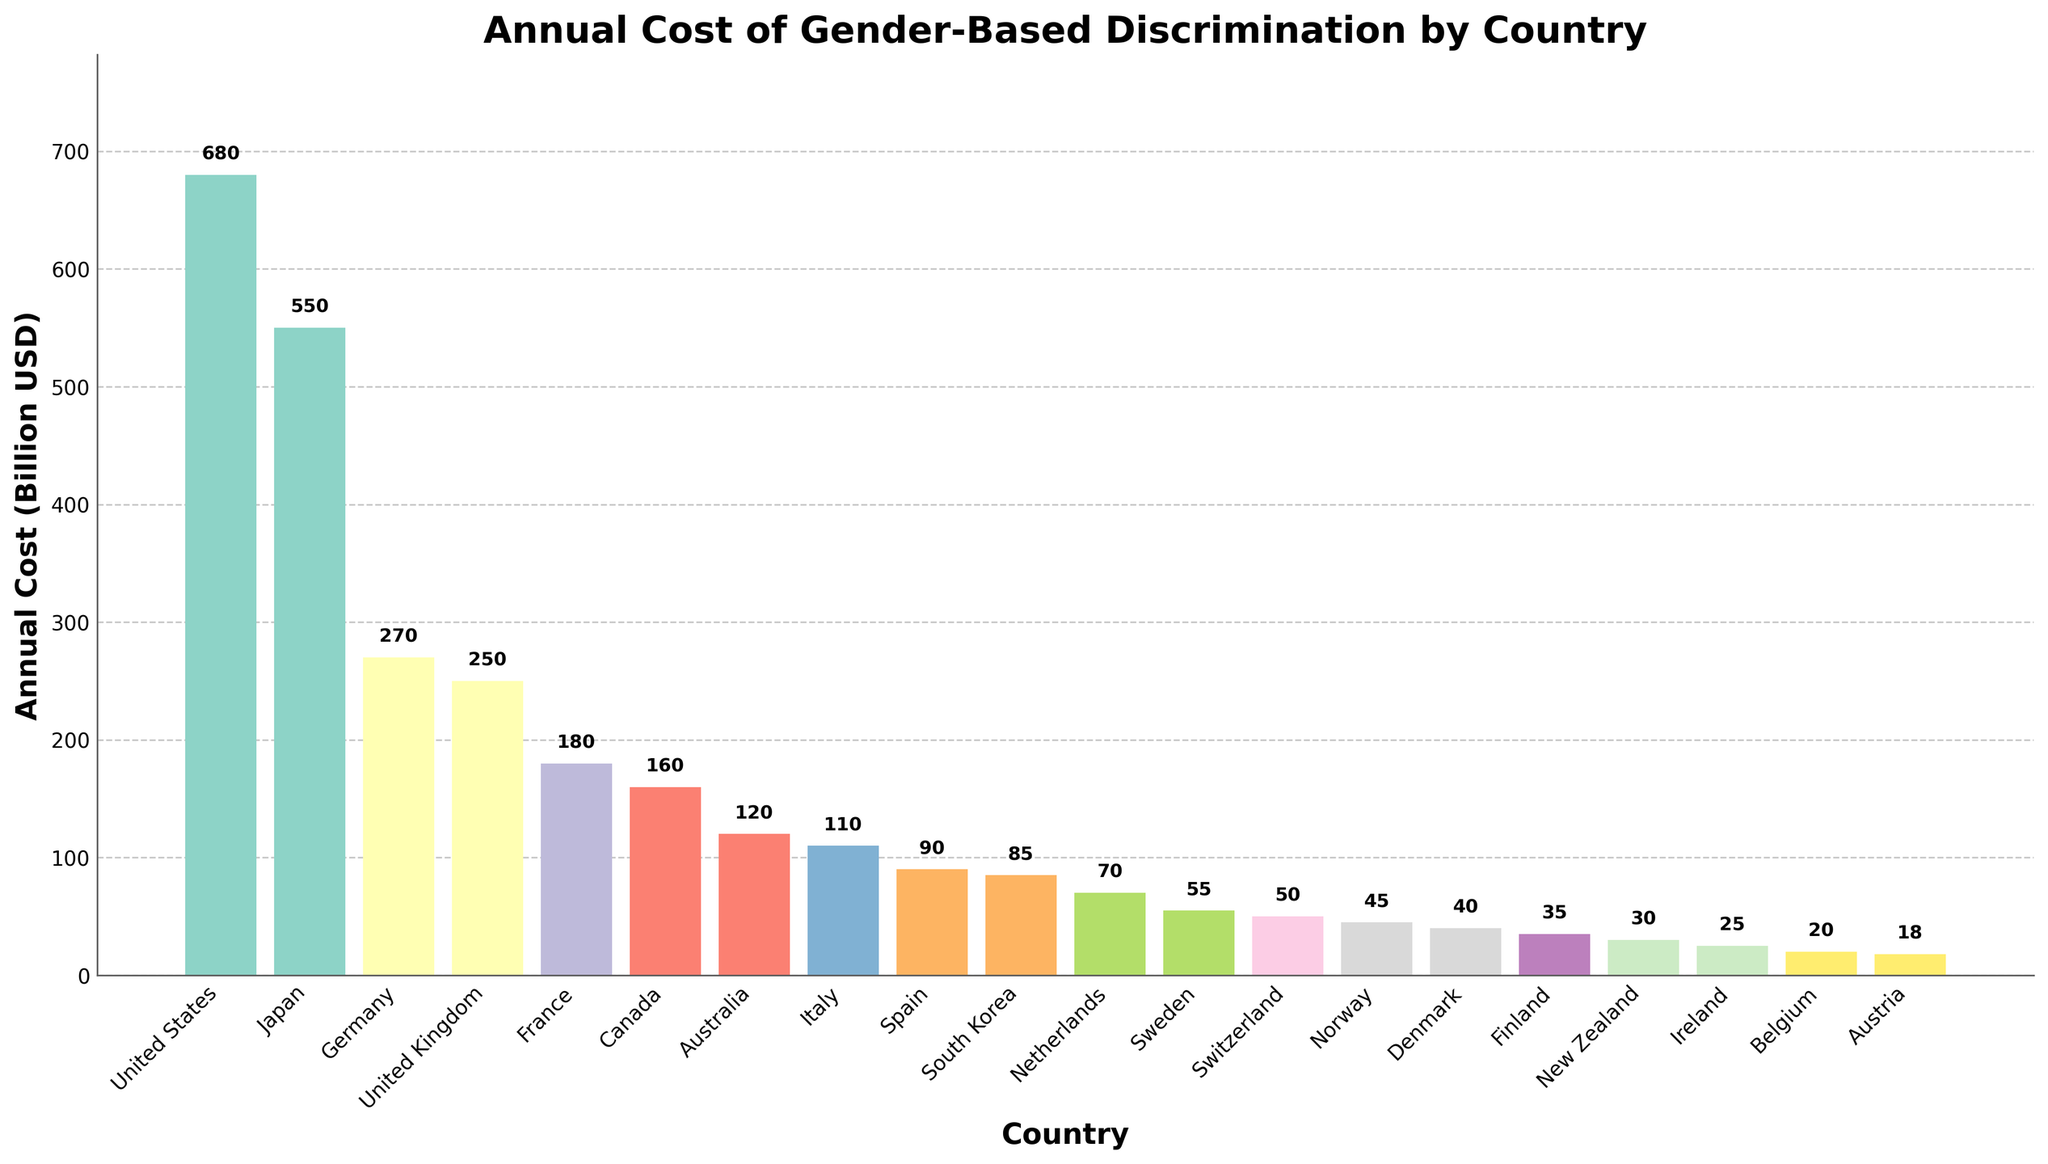What's the country with the highest annual cost of gender-based discrimination? The country with the highest annual cost can be determined by identifying the highest bar in the chart. The United States has the highest bar.
Answer: United States Which country has a lower annual cost of gender-based discrimination: Italy or Australia? To determine this, compare the heights of the bars for Italy and Australia. The bar for Italy is shorter than the bar for Australia, indicating a lower cost.
Answer: Italy What is the total annual cost of gender-based discrimination for the top three countries? Identify the top three countries by the height of their bars (United States, Japan, Germany) and sum their costs: 680 + 550 + 270 = 1500
Answer: 1500 How does the annual cost of gender-based discrimination in Canada compare to the cost in the United Kingdom? Look at the bars for Canada and the United Kingdom. The bar for Canada is shorter than the bar for the United Kingdom, indicating a lower cost.
Answer: Lower What's the approximate average annual cost of gender-based discrimination for the countries with costs listed between 25 and 90 Billion USD? Identify the countries in the 25-90 range (New Zealand, Finland, Denmark, Norway, Switzerland, Sweden, Netherlands, South Korea, Spain) and calculate the average: (30 + 35 + 40 + 45 + 50 + 55 + 70 + 85 + 90) / 9 = 500 / 9 ≈ 55.56
Answer: 55.56 What is the difference in annual cost between France and Spain? Find the bars for France and Spain, then subtract the cost for Spain from the cost for France: 180 - 90 = 90
Answer: 90 Which countries have an annual cost greater than 100 Billion USD? Identify the countries with bars taller than the height representing 100 Billion USD (United States, Japan, Germany, United Kingdom, France, Canada, Australia, Italy).
Answer: United States, Japan, Germany, United Kingdom, France, Canada, Australia, Italy What is the average annual cost of gender-based discrimination for the listed countries? Sum all the listed costs and then divide by the number of countries: (680 + 550 + 270 + 250 + 180 + 160 + 120 + 110 + 90 + 85 + 70 + 55 + 50 + 45 + 40 + 35 + 30 + 25 + 20 + 18) / 20 = 2863 / 20 = 143.15
Answer: 143.15 What's the median annual cost of gender-based discrimination for the listed countries? Sort the costs in ascending order and find the middle value. If there's an even number of data points, average the two middle values: [(18 + 20 + 25 + 30 + 35 + 40 + 45 + 50 + 55 + 70 + 85 + 90 + 110 + 120 + 160 + 180 + 250 + 270 + 550 + 680) / 2] = (55 + 70)/2 = 62.5
Answer: 62.5 